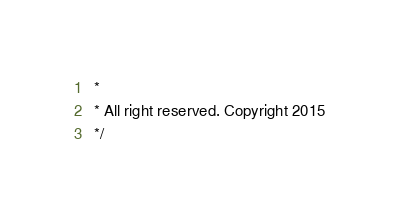<code> <loc_0><loc_0><loc_500><loc_500><_JavaScript_> *
 * All right reserved. Copyright 2015 
 */</code> 